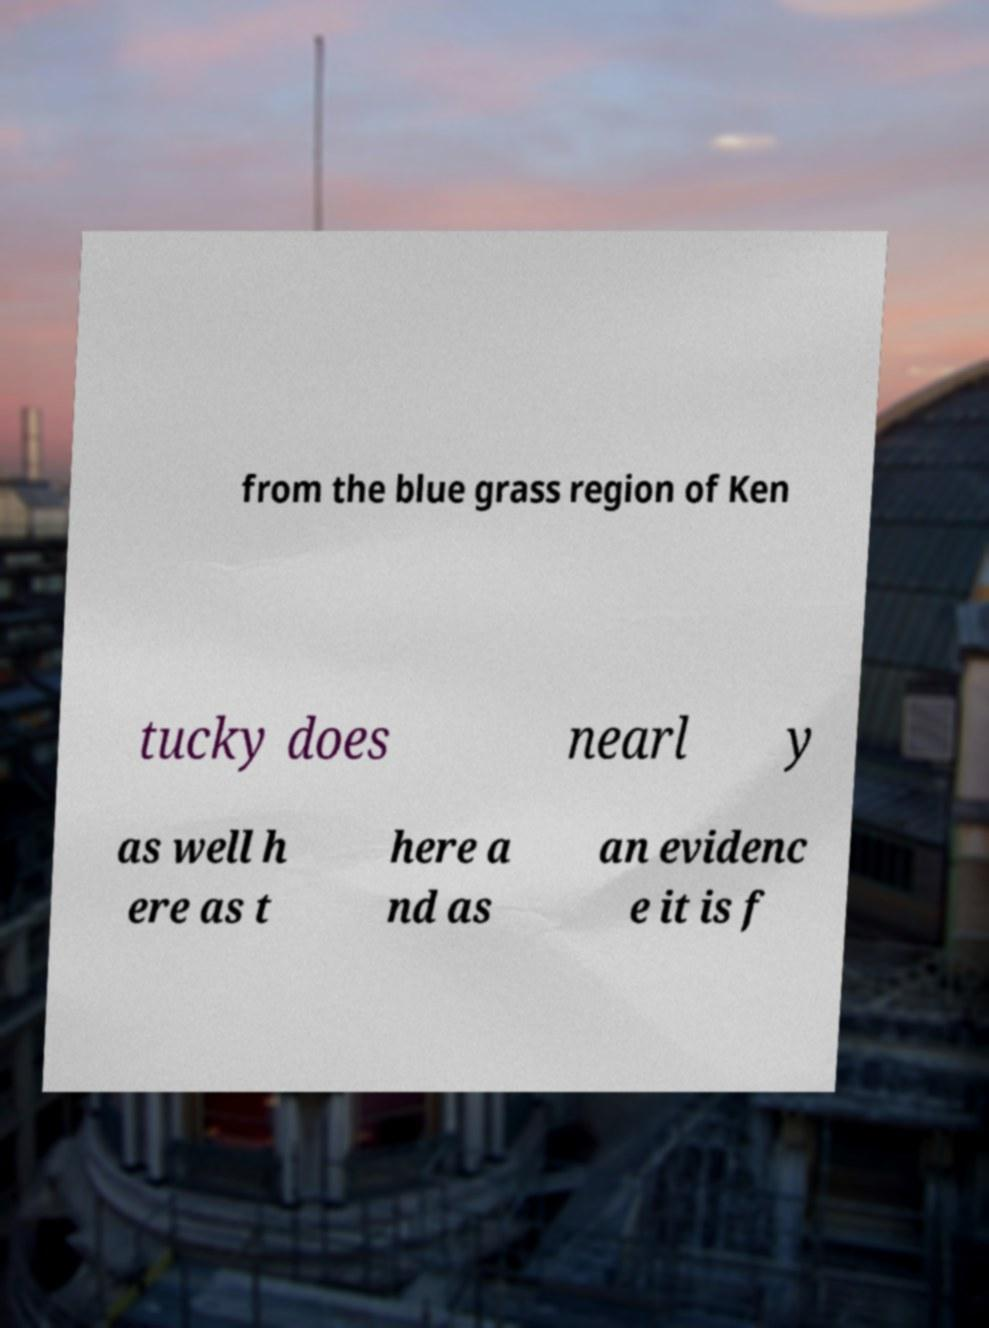Could you extract and type out the text from this image? from the blue grass region of Ken tucky does nearl y as well h ere as t here a nd as an evidenc e it is f 